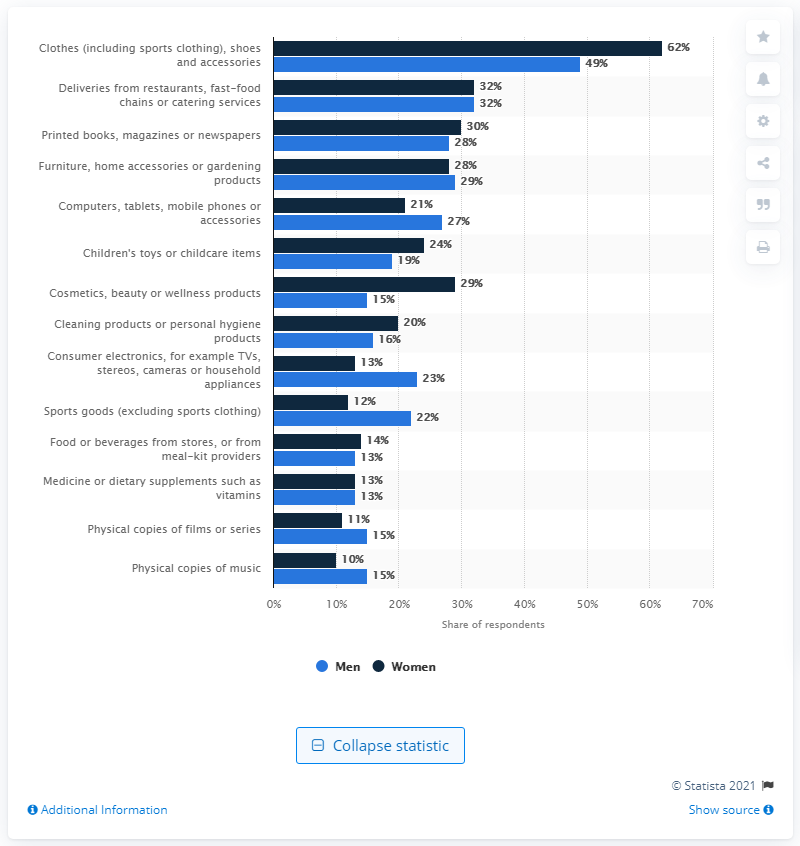Draw attention to some important aspects in this diagram. It is estimated that 49% of men in Great Britain purchased clothing products in 2020. In 2020, it was found that 49% of men in Great Britain had purchased clothing products. 